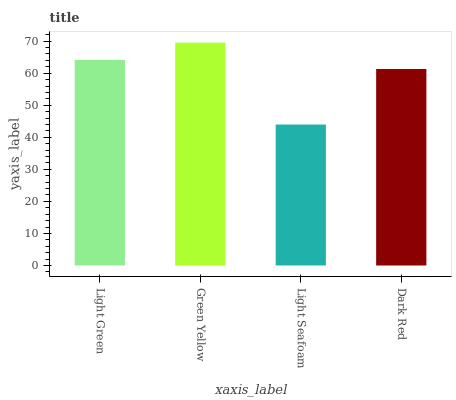Is Light Seafoam the minimum?
Answer yes or no. Yes. Is Green Yellow the maximum?
Answer yes or no. Yes. Is Green Yellow the minimum?
Answer yes or no. No. Is Light Seafoam the maximum?
Answer yes or no. No. Is Green Yellow greater than Light Seafoam?
Answer yes or no. Yes. Is Light Seafoam less than Green Yellow?
Answer yes or no. Yes. Is Light Seafoam greater than Green Yellow?
Answer yes or no. No. Is Green Yellow less than Light Seafoam?
Answer yes or no. No. Is Light Green the high median?
Answer yes or no. Yes. Is Dark Red the low median?
Answer yes or no. Yes. Is Light Seafoam the high median?
Answer yes or no. No. Is Light Seafoam the low median?
Answer yes or no. No. 